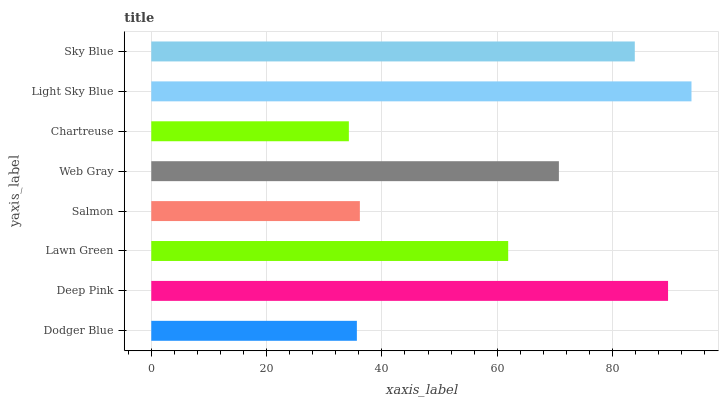Is Chartreuse the minimum?
Answer yes or no. Yes. Is Light Sky Blue the maximum?
Answer yes or no. Yes. Is Deep Pink the minimum?
Answer yes or no. No. Is Deep Pink the maximum?
Answer yes or no. No. Is Deep Pink greater than Dodger Blue?
Answer yes or no. Yes. Is Dodger Blue less than Deep Pink?
Answer yes or no. Yes. Is Dodger Blue greater than Deep Pink?
Answer yes or no. No. Is Deep Pink less than Dodger Blue?
Answer yes or no. No. Is Web Gray the high median?
Answer yes or no. Yes. Is Lawn Green the low median?
Answer yes or no. Yes. Is Sky Blue the high median?
Answer yes or no. No. Is Light Sky Blue the low median?
Answer yes or no. No. 